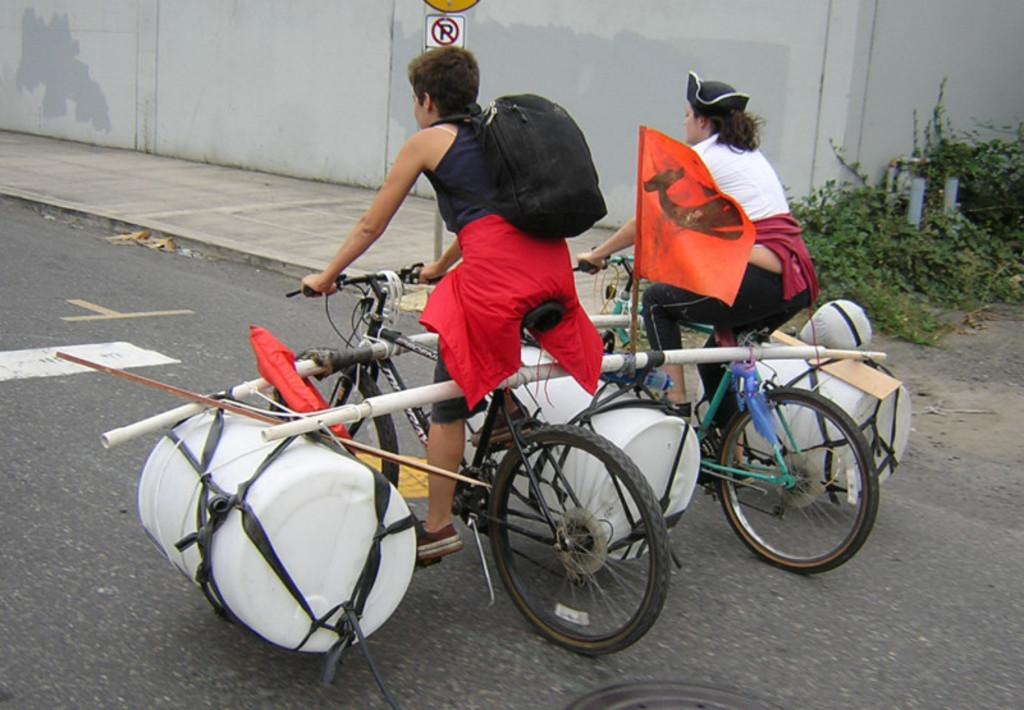How many people are in the image? There are two persons in the image. What are the persons doing in the image? The persons are on a cycle. What can be seen on the cycle? There are things on the cycle. What is present in the image besides the cycle and the persons? There is a flag in the image, as well as a sign board and plants in the background. What can be seen on the ground in the background? There is a path visible in the background. What type of nerve can be seen stimulating the development of jelly in the image? There is no nerve or jelly present in the image; it features two persons on a cycle with additional items and a background setting. 